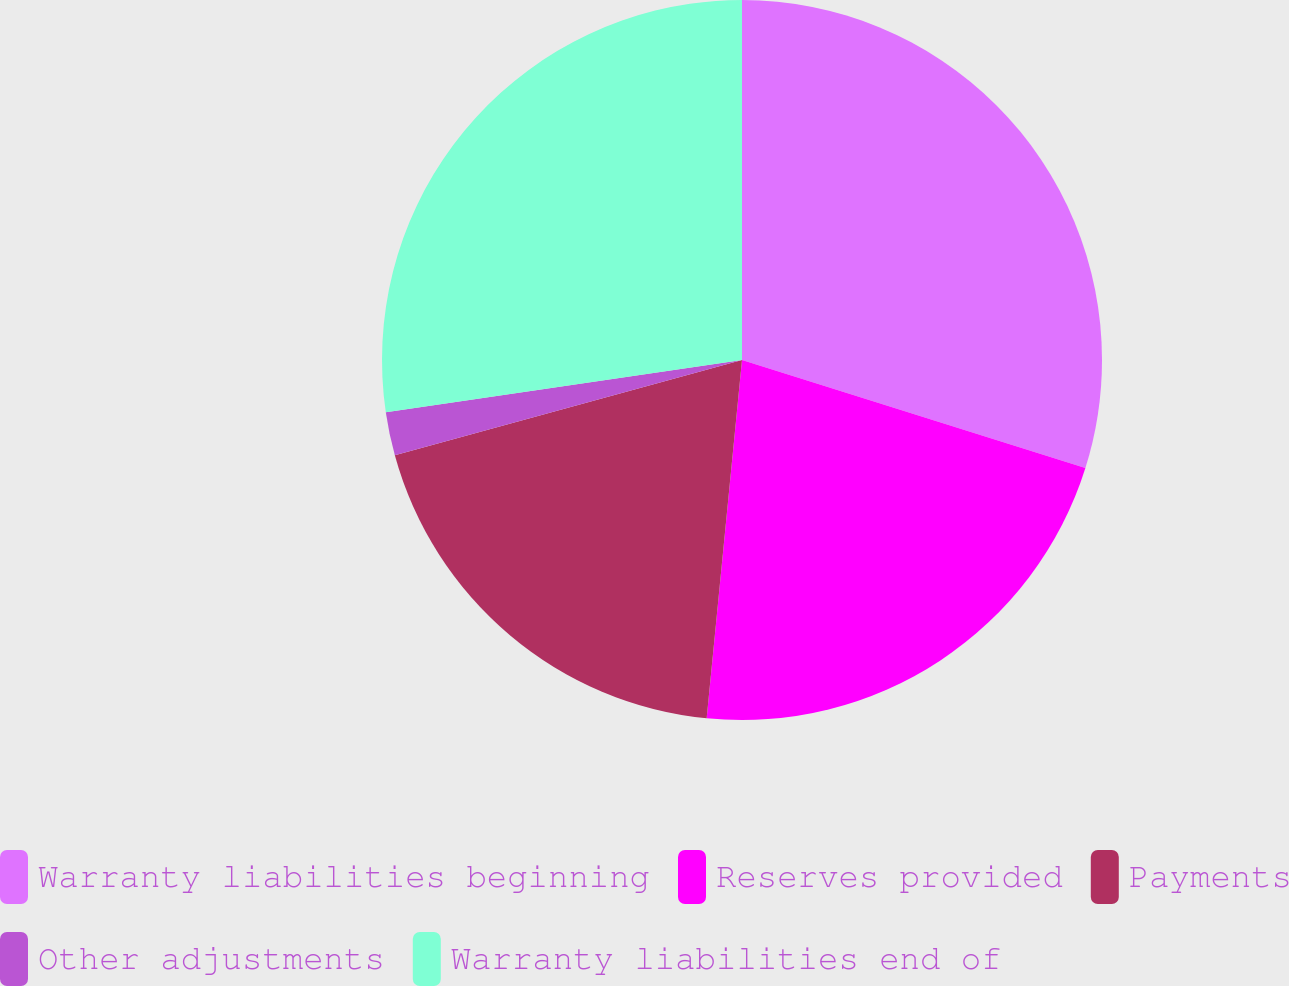Convert chart to OTSL. <chart><loc_0><loc_0><loc_500><loc_500><pie_chart><fcel>Warranty liabilities beginning<fcel>Reserves provided<fcel>Payments<fcel>Other adjustments<fcel>Warranty liabilities end of<nl><fcel>29.85%<fcel>21.71%<fcel>19.17%<fcel>1.95%<fcel>27.31%<nl></chart> 